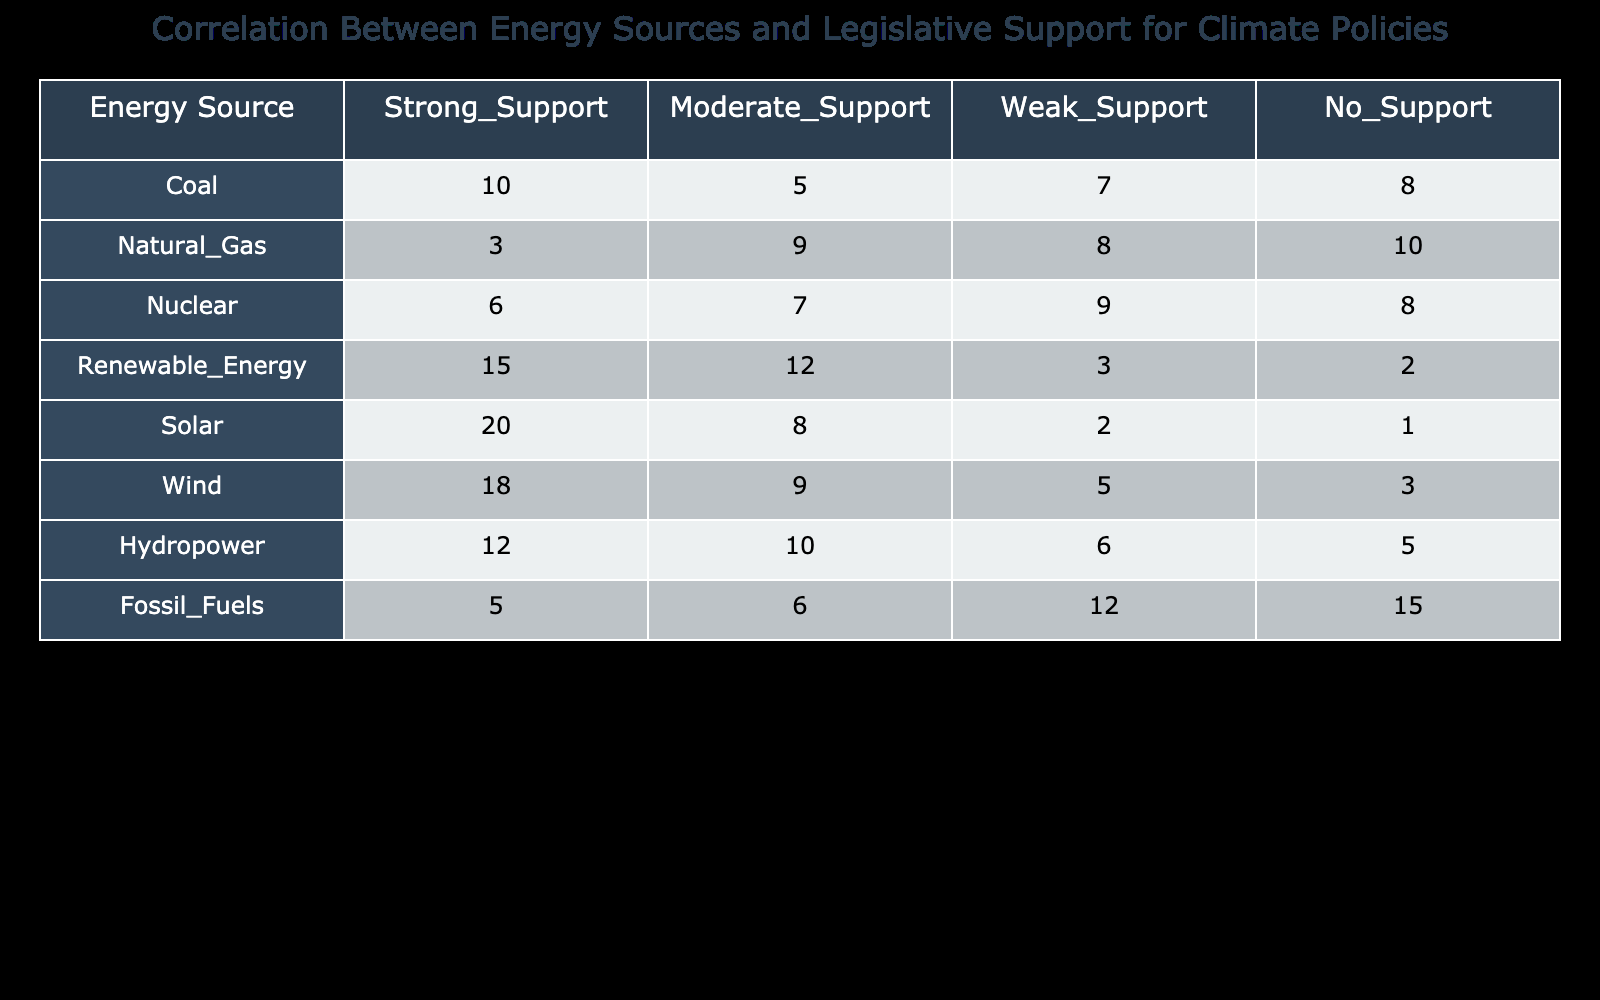What is the highest number of strong support votes among energy sources? By looking at the "Strong Support" column in the table, we find that Solar has the highest count of 20 votes, as compared to other energy sources.
Answer: 20 Which energy source has the least amount of moderate support? In the "Moderate Support" column, the energy source with the least amount of supportive votes is Solar, with only 8 votes, which is fewer than Wind and all other sources listed.
Answer: 8 How many total votes does Renewable Energy have across all support categories? To find the total for Renewable Energy, we add the votes across all columns: 15 (Strong) + 12 (Moderate) + 3 (Weak) + 2 (No) = 32.
Answer: 32 Is it true that Coal has more strong support than Natural Gas? Looking at the "Strong Support" column, Coal has 10 votes while Natural Gas has only 3 votes, so it is true that Coal has more strong support than Natural Gas.
Answer: Yes What is the average number of weak support votes across all energy sources? To get the average for weak support, we sum all the weak support votes: 7 + 8 + 9 + 3 + 2 + 5 + 6 + 12 = 52. There are 8 energy sources, so we divide 52 by 8 which gives us 52/8 = 6.5.
Answer: 6.5 Do any energy sources have more than 10 votes in moderate support? Checking the “Moderate Support” column, both Natural Gas (9) and Nuclear (7) have fewer than 10 votes, while Renewable Energy (12), Wind (9), and Hydropower (10) also do not exceed 10 votes. Therefore, it is false that any energy sources have more than 10 votes in moderate support.
Answer: No What is the difference in the number of weak support votes between Fossil Fuels and Renewable Energy? For Fossil Fuels, the weak support votes are 12, and for Renewable Energy, it is 3. The difference is 12 - 3 = 9, meaning Fossil Fuels has 9 more weak support votes than Renewable Energy.
Answer: 9 Which energy source has the highest total number of votes across all categories? We calculate the total votes for each energy source. Solar has 31 (20+8+2+1), Wind has 35 (18+9+5+3), and Renewable Energy has 32. Wind has the highest total at 35.
Answer: Wind 